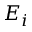<formula> <loc_0><loc_0><loc_500><loc_500>E _ { i }</formula> 